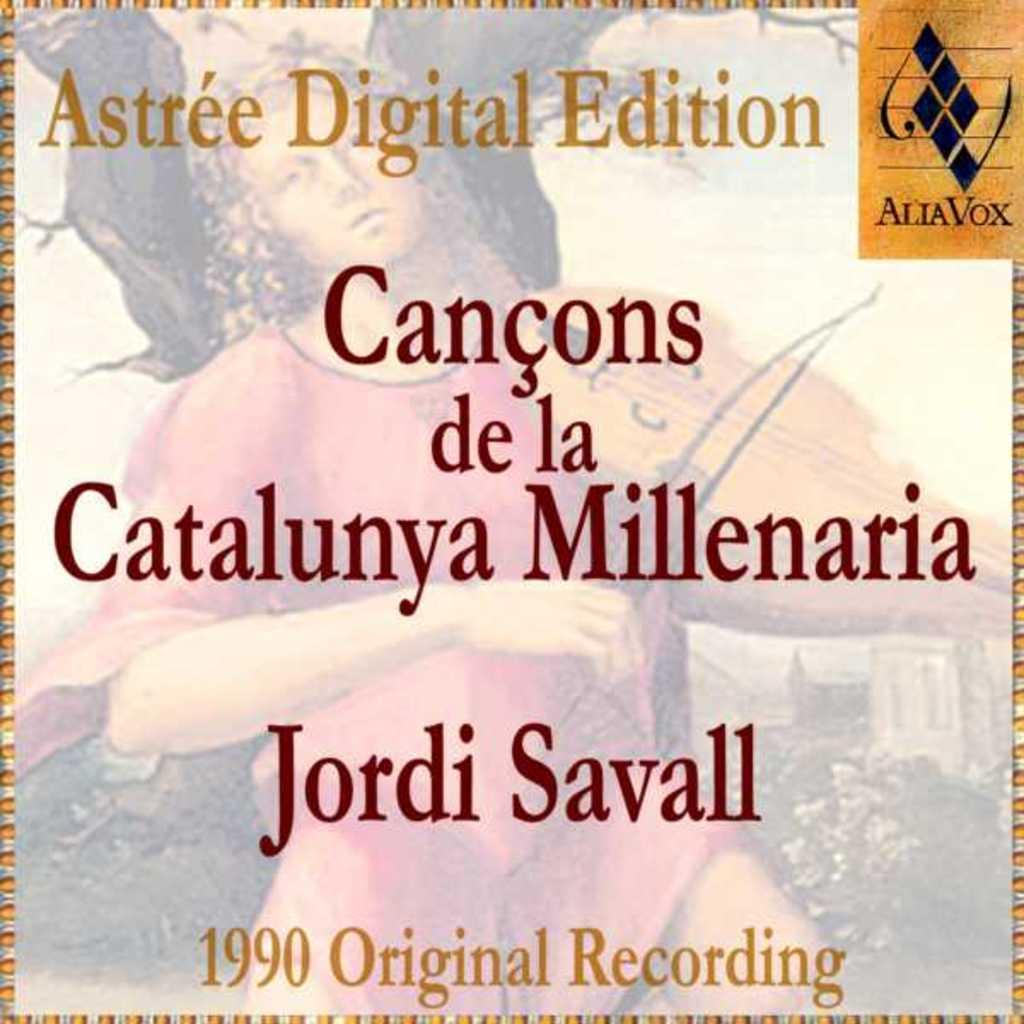<image>
Give a short and clear explanation of the subsequent image. an 1990 original audio recordings by jordi savall 